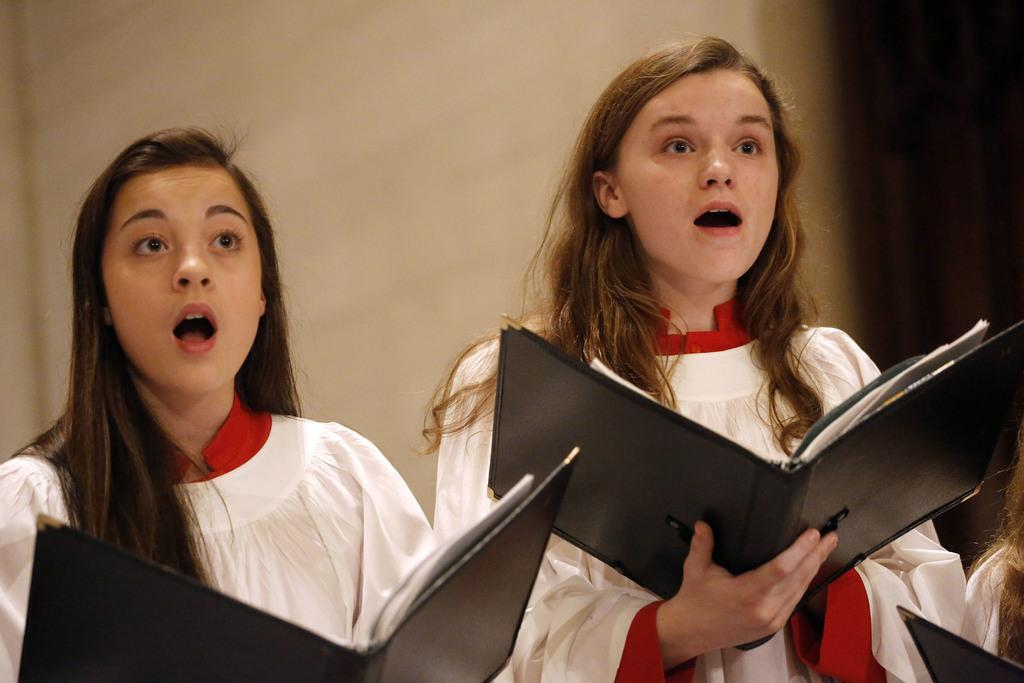What can be seen in the image? There is a group of women in the image. What are the women doing? The women are standing and holding files in their hands. What is visible at the top of the image? There is a wall visible at the top of the image. What type of corn is growing on the wall in the image? There is no corn present in the image; the wall is visible but not growing any corn. 